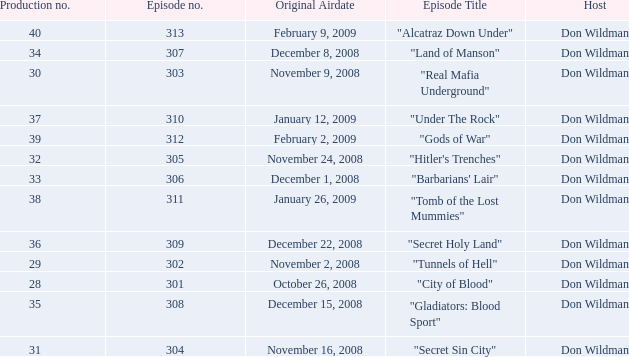What is the episode number of the episode that originally aired on January 26, 2009 and had a production number smaller than 38? 0.0. 